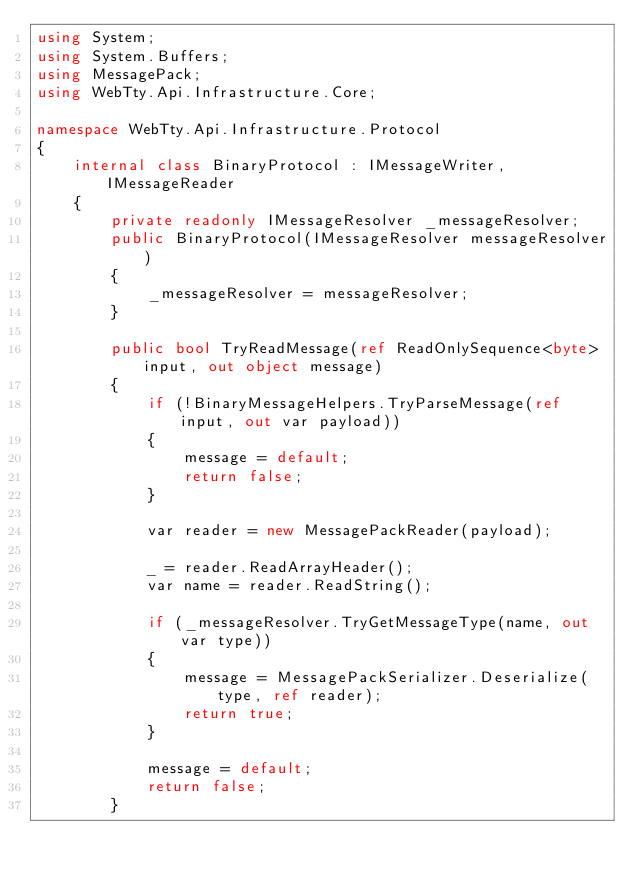<code> <loc_0><loc_0><loc_500><loc_500><_C#_>using System;
using System.Buffers;
using MessagePack;
using WebTty.Api.Infrastructure.Core;

namespace WebTty.Api.Infrastructure.Protocol
{
    internal class BinaryProtocol : IMessageWriter, IMessageReader
    {
        private readonly IMessageResolver _messageResolver;
        public BinaryProtocol(IMessageResolver messageResolver)
        {
            _messageResolver = messageResolver;
        }

        public bool TryReadMessage(ref ReadOnlySequence<byte> input, out object message)
        {
            if (!BinaryMessageHelpers.TryParseMessage(ref input, out var payload))
            {
                message = default;
                return false;
            }

            var reader = new MessagePackReader(payload);

            _ = reader.ReadArrayHeader();
            var name = reader.ReadString();

            if (_messageResolver.TryGetMessageType(name, out var type))
            {
                message = MessagePackSerializer.Deserialize(type, ref reader);
                return true;
            }

            message = default;
            return false;
        }
</code> 